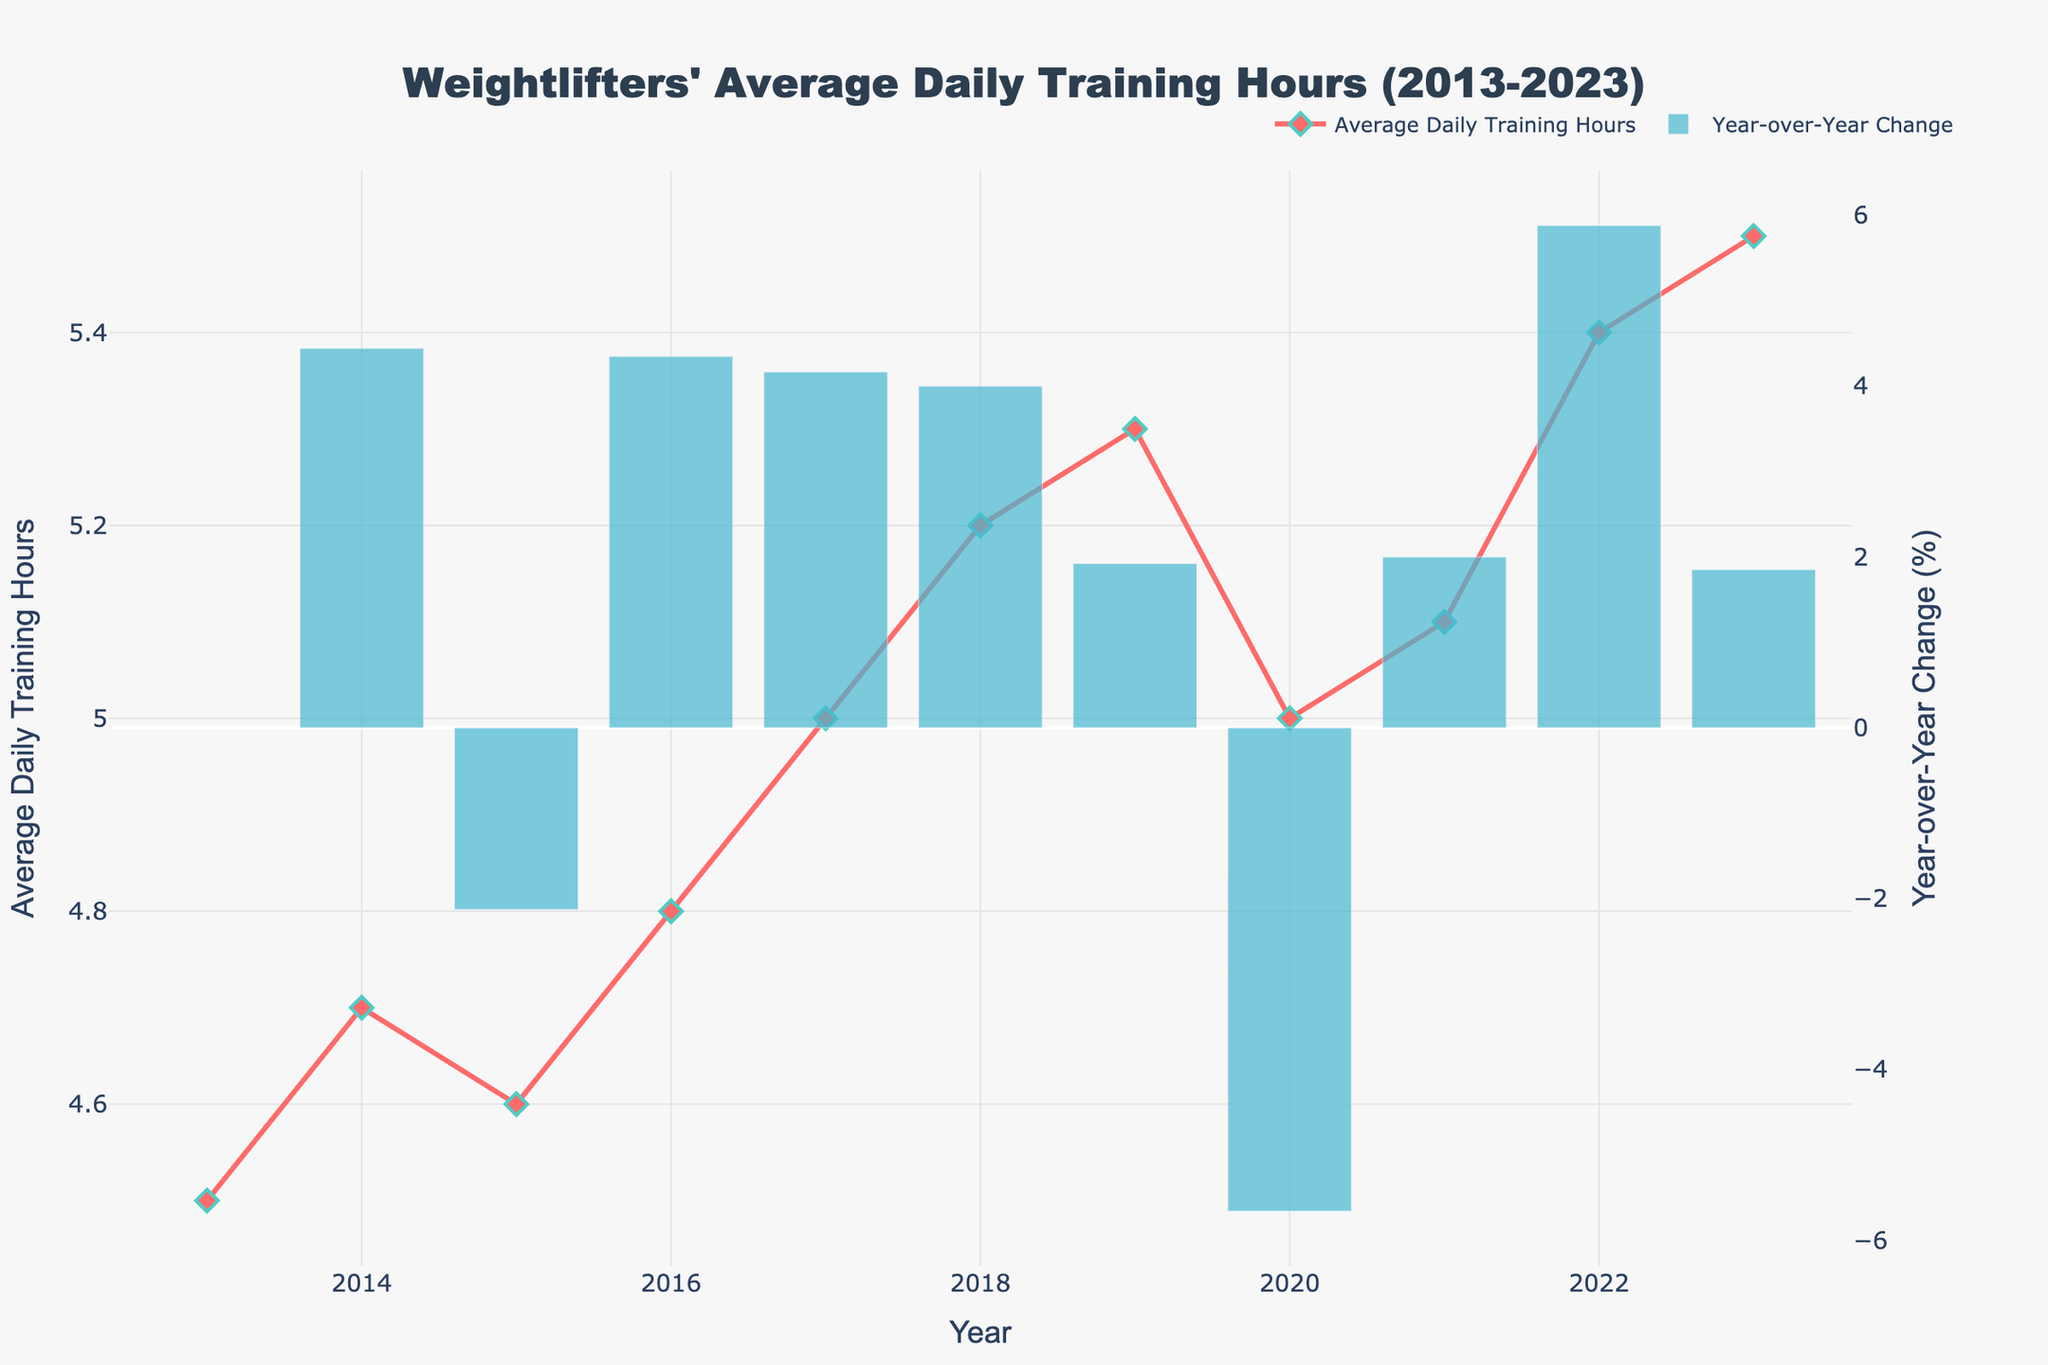What is the title of the figure? The title is usually placed at the top of the figure and is clearly labeled to describe what the plot is about.
Answer: Weightlifters' Average Daily Training Hours (2013-2023) What is the average daily training time for weightlifters in 2016? The plot shows the average daily training hours on the y-axis, and the corresponding value for 2016 can be read from the year 2016 on the x-axis. It is clearly marked by a diamond symbol.
Answer: 4.8 hours How much did the average daily training hours increase from 2019 to 2020? Locate the value for 2019 (5.3 hours) and 2020 (5.0 hours) from the plot, then calculate the difference by subtracting the latter from the former.
Answer: -0.3 hours Between which two years was the year-over-year change in average daily training hours the highest? Identify bars representing the year-over-year change for each year in the plot. The highest bar indicates the year with the highest increase compared to its previous year.
Answer: 2017 to 2018 What was the general trend of average daily training hours from 2013 to 2023? Look at the line connecting the points for each year representing the average daily training hours. Identify if it is generally increasing, decreasing, or remaining constant.
Answer: Increasing Did the average daily training hours ever decrease compared to the previous year? If so, which year(s)? Examine the YoY Change bars for any negative values, and their corresponding years directly below on the x-axis.
Answer: Yes, from 2019 to 2020 What was the year-over-year change in average daily training hours from 2021 to 2022? Identify the bar representing YoY Change for 2022, and note the value in percentage terms.
Answer: ~5.9% Calculate the total increase in average daily training hours from 2013 to 2023. Subtract the 2013 value (4.5 hours) from the 2023 value (5.5 hours).
Answer: 1.0 hours How did the average daily training hours change between 2017 and 2020? Assess the values for 2017 (5.0 hours), 2018 (5.2 hours), 2019 (5.3 hours), and 2020 (5.0 hours). Summarize the changes.
Answer: Increased, then slightly decreased Which year had the smallest year-over-year change in average daily training hours? Look for the smallest bar representing YoY Change across all the years. Note the corresponding year.
Answer: 2014 